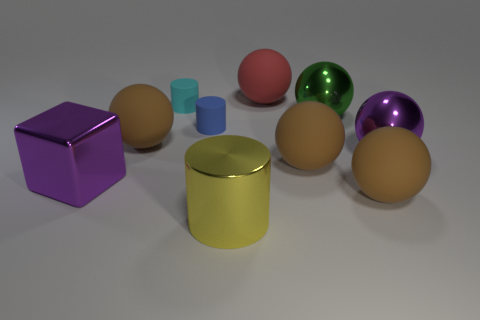What material is the large green thing that is the same shape as the red rubber object?
Your response must be concise. Metal. What number of brown metal cylinders are there?
Provide a succinct answer. 0. There is a big purple thing that is left of the blue cylinder; is its shape the same as the red matte thing?
Your answer should be compact. No. What material is the red object that is the same size as the purple shiny cube?
Keep it short and to the point. Rubber. Are there any big things that have the same material as the purple block?
Give a very brief answer. Yes. There is a large green object; does it have the same shape as the tiny matte thing that is left of the tiny blue rubber cylinder?
Provide a succinct answer. No. How many objects are behind the large green object and right of the metallic cylinder?
Keep it short and to the point. 1. Does the big cylinder have the same material as the big brown ball that is behind the large purple ball?
Your answer should be compact. No. Are there an equal number of metal spheres in front of the big purple metal ball and small blue rubber things?
Keep it short and to the point. No. The rubber ball that is on the left side of the blue cylinder is what color?
Keep it short and to the point. Brown. 